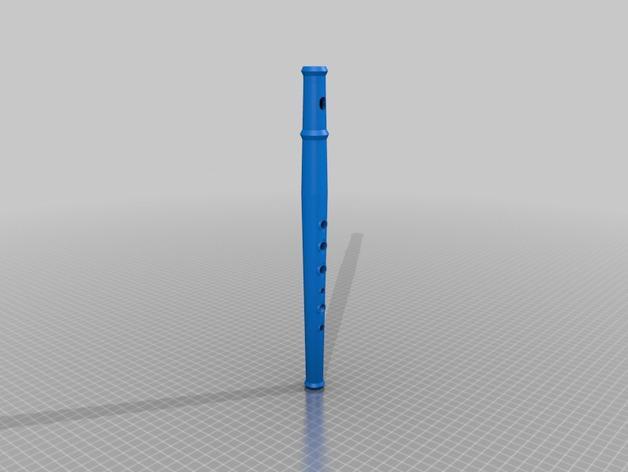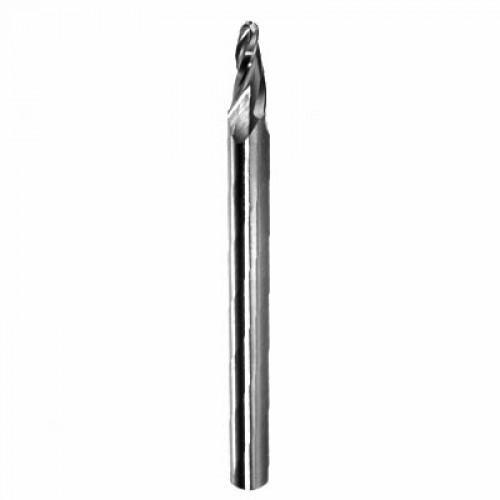The first image is the image on the left, the second image is the image on the right. Evaluate the accuracy of this statement regarding the images: "There is a solid metal thing with no visible holes in the right image.". Is it true? Answer yes or no. Yes. The first image is the image on the left, the second image is the image on the right. For the images shown, is this caption "There is exactly one flute." true? Answer yes or no. Yes. 